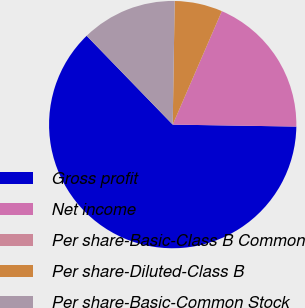<chart> <loc_0><loc_0><loc_500><loc_500><pie_chart><fcel>Gross profit<fcel>Net income<fcel>Per share-Basic-Class B Common<fcel>Per share-Diluted-Class B<fcel>Per share-Basic-Common Stock<nl><fcel>62.5%<fcel>18.75%<fcel>0.0%<fcel>6.25%<fcel>12.5%<nl></chart> 